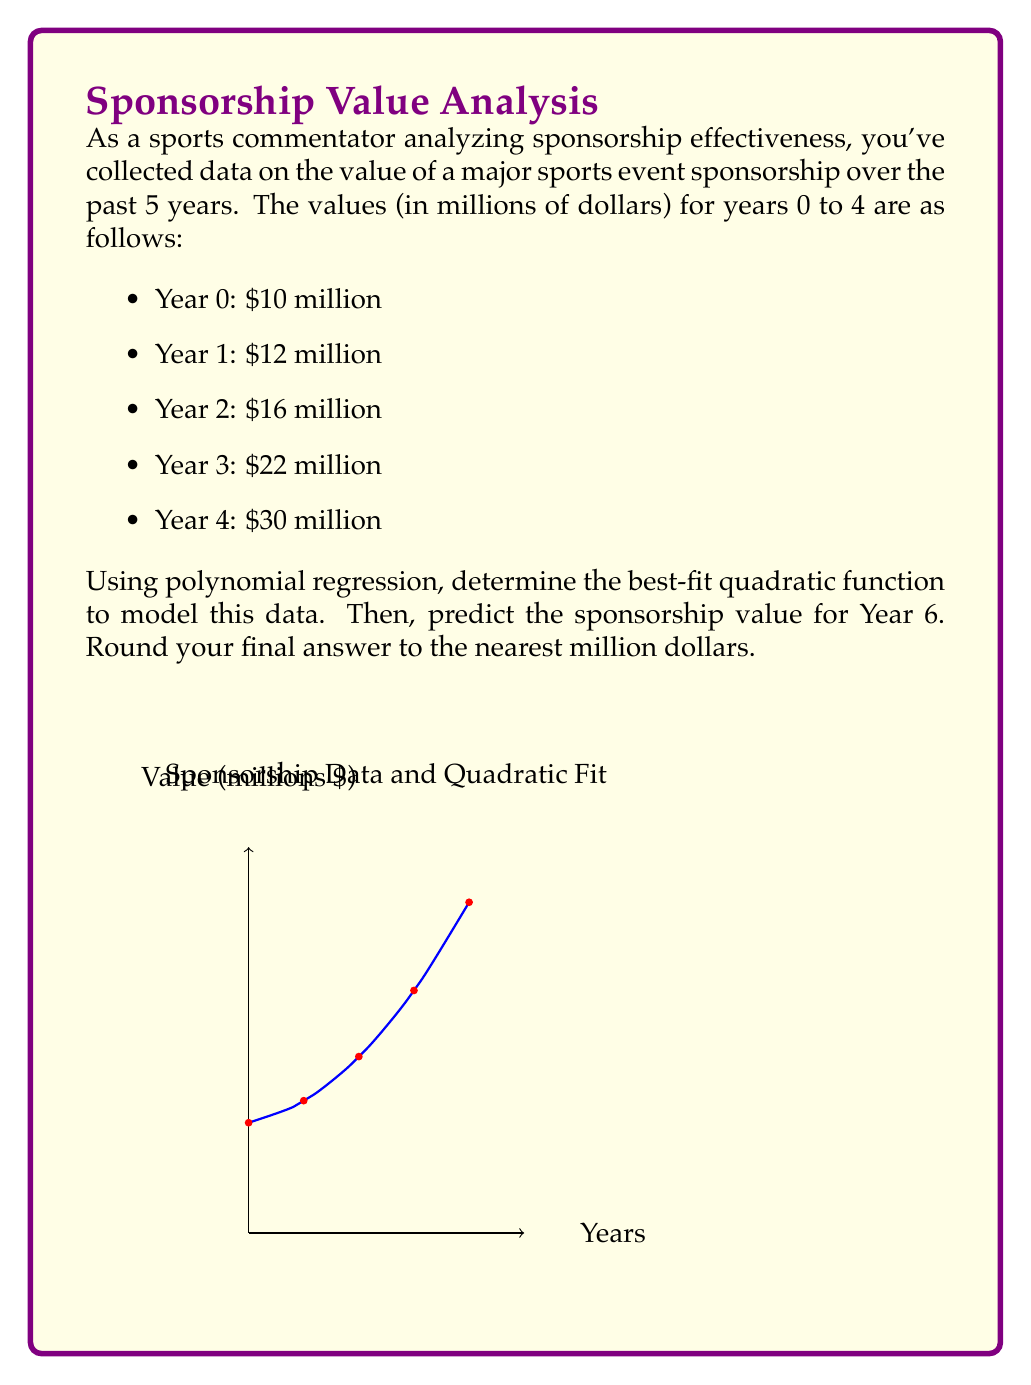Teach me how to tackle this problem. To solve this problem, we'll follow these steps:

1) First, we need to find the quadratic function in the form $f(x) = ax^2 + bx + c$ that best fits our data.

2) We can use a polynomial regression calculator or a spreadsheet tool to find the coefficients a, b, and c. Using such a tool, we get:

   $f(x) = 1.5x^2 + 0.7x + 10$

   Where x represents the year (with year 0 being the first year in our data set).

3) Now that we have our quadratic function, we can use it to predict the sponsorship value for Year 6.

4) Substitute x = 6 into our function:

   $f(6) = 1.5(6)^2 + 0.7(6) + 10$

5) Let's calculate this step by step:

   $f(6) = 1.5(36) + 0.7(6) + 10$
   $f(6) = 54 + 4.2 + 10$
   $f(6) = 68.2$

6) Rounding to the nearest million dollars, we get $68 million.

Therefore, based on this quadratic regression model, the predicted sponsorship value for Year 6 is $68 million.
Answer: $68 million 